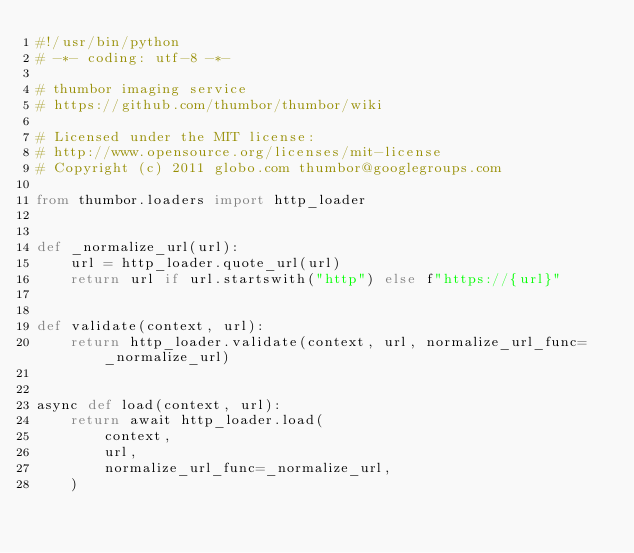Convert code to text. <code><loc_0><loc_0><loc_500><loc_500><_Python_>#!/usr/bin/python
# -*- coding: utf-8 -*-

# thumbor imaging service
# https://github.com/thumbor/thumbor/wiki

# Licensed under the MIT license:
# http://www.opensource.org/licenses/mit-license
# Copyright (c) 2011 globo.com thumbor@googlegroups.com

from thumbor.loaders import http_loader


def _normalize_url(url):
    url = http_loader.quote_url(url)
    return url if url.startswith("http") else f"https://{url}"


def validate(context, url):
    return http_loader.validate(context, url, normalize_url_func=_normalize_url)


async def load(context, url):
    return await http_loader.load(
        context,
        url,
        normalize_url_func=_normalize_url,
    )
</code> 